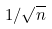Convert formula to latex. <formula><loc_0><loc_0><loc_500><loc_500>1 / \sqrt { n }</formula> 